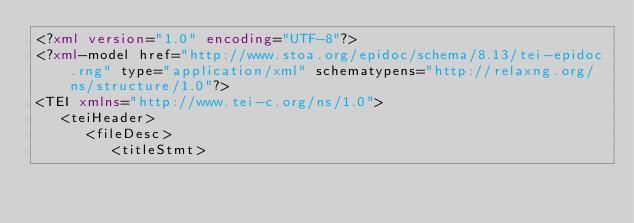<code> <loc_0><loc_0><loc_500><loc_500><_XML_><?xml version="1.0" encoding="UTF-8"?>
<?xml-model href="http://www.stoa.org/epidoc/schema/8.13/tei-epidoc.rng" type="application/xml" schematypens="http://relaxng.org/ns/structure/1.0"?>
<TEI xmlns="http://www.tei-c.org/ns/1.0">
   <teiHeader>
      <fileDesc>
         <titleStmt></code> 